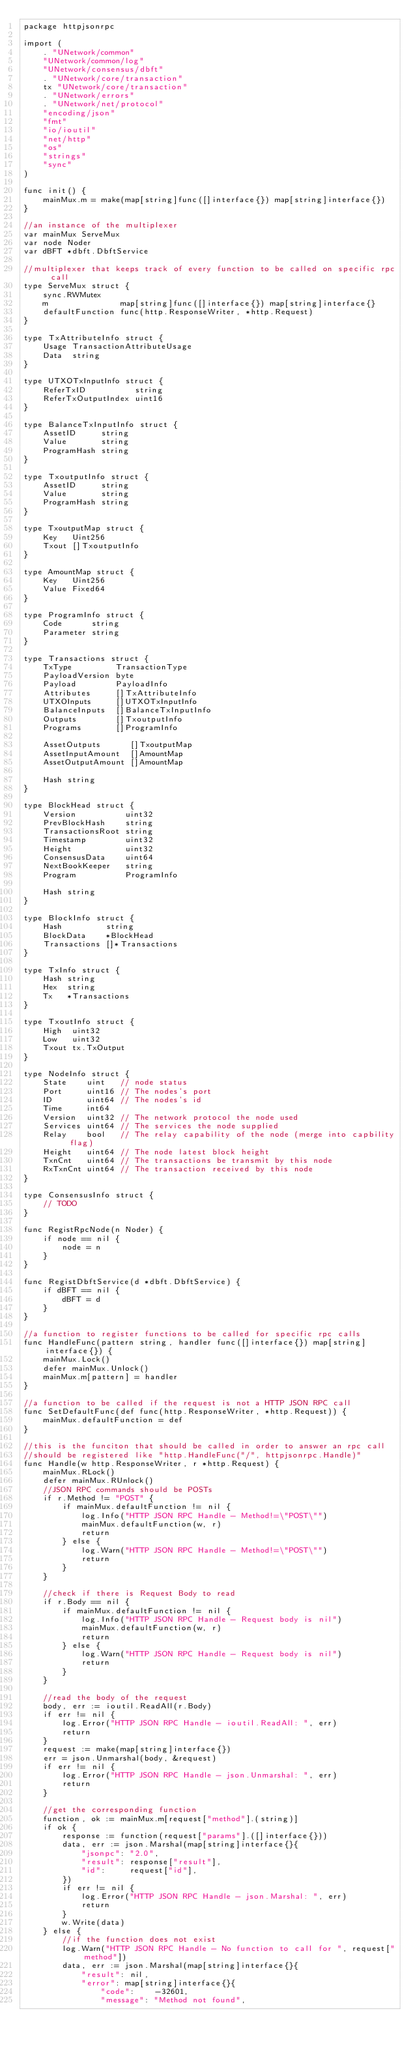<code> <loc_0><loc_0><loc_500><loc_500><_Go_>package httpjsonrpc

import (
	. "UNetwork/common"
	"UNetwork/common/log"
	"UNetwork/consensus/dbft"
	. "UNetwork/core/transaction"
	tx "UNetwork/core/transaction"
	. "UNetwork/errors"
	. "UNetwork/net/protocol"
	"encoding/json"
	"fmt"
	"io/ioutil"
	"net/http"
	"os"
	"strings"
	"sync"
)

func init() {
	mainMux.m = make(map[string]func([]interface{}) map[string]interface{})
}

//an instance of the multiplexer
var mainMux ServeMux
var node Noder
var dBFT *dbft.DbftService

//multiplexer that keeps track of every function to be called on specific rpc call
type ServeMux struct {
	sync.RWMutex
	m               map[string]func([]interface{}) map[string]interface{}
	defaultFunction func(http.ResponseWriter, *http.Request)
}

type TxAttributeInfo struct {
	Usage TransactionAttributeUsage
	Data  string
}

type UTXOTxInputInfo struct {
	ReferTxID          string
	ReferTxOutputIndex uint16
}

type BalanceTxInputInfo struct {
	AssetID     string
	Value       string
	ProgramHash string
}

type TxoutputInfo struct {
	AssetID     string
	Value       string
	ProgramHash string
}

type TxoutputMap struct {
	Key   Uint256
	Txout []TxoutputInfo
}

type AmountMap struct {
	Key   Uint256
	Value Fixed64
}

type ProgramInfo struct {
	Code      string
	Parameter string
}

type Transactions struct {
	TxType         TransactionType
	PayloadVersion byte
	Payload        PayloadInfo
	Attributes     []TxAttributeInfo
	UTXOInputs     []UTXOTxInputInfo
	BalanceInputs  []BalanceTxInputInfo
	Outputs        []TxoutputInfo
	Programs       []ProgramInfo

	AssetOutputs      []TxoutputMap
	AssetInputAmount  []AmountMap
	AssetOutputAmount []AmountMap

	Hash string
}

type BlockHead struct {
	Version          uint32
	PrevBlockHash    string
	TransactionsRoot string
	Timestamp        uint32
	Height           uint32
	ConsensusData    uint64
	NextBookKeeper   string
	Program          ProgramInfo

	Hash string
}

type BlockInfo struct {
	Hash         string
	BlockData    *BlockHead
	Transactions []*Transactions
}

type TxInfo struct {
	Hash string
	Hex  string
	Tx   *Transactions
}

type TxoutInfo struct {
	High  uint32
	Low   uint32
	Txout tx.TxOutput
}

type NodeInfo struct {
	State    uint   // node status
	Port     uint16 // The nodes's port
	ID       uint64 // The nodes's id
	Time     int64
	Version  uint32 // The network protocol the node used
	Services uint64 // The services the node supplied
	Relay    bool   // The relay capability of the node (merge into capbility flag)
	Height   uint64 // The node latest block height
	TxnCnt   uint64 // The transactions be transmit by this node
	RxTxnCnt uint64 // The transaction received by this node
}

type ConsensusInfo struct {
	// TODO
}

func RegistRpcNode(n Noder) {
	if node == nil {
		node = n
	}
}

func RegistDbftService(d *dbft.DbftService) {
	if dBFT == nil {
		dBFT = d
	}
}

//a function to register functions to be called for specific rpc calls
func HandleFunc(pattern string, handler func([]interface{}) map[string]interface{}) {
	mainMux.Lock()
	defer mainMux.Unlock()
	mainMux.m[pattern] = handler
}

//a function to be called if the request is not a HTTP JSON RPC call
func SetDefaultFunc(def func(http.ResponseWriter, *http.Request)) {
	mainMux.defaultFunction = def
}

//this is the funciton that should be called in order to answer an rpc call
//should be registered like "http.HandleFunc("/", httpjsonrpc.Handle)"
func Handle(w http.ResponseWriter, r *http.Request) {
	mainMux.RLock()
	defer mainMux.RUnlock()
	//JSON RPC commands should be POSTs
	if r.Method != "POST" {
		if mainMux.defaultFunction != nil {
			log.Info("HTTP JSON RPC Handle - Method!=\"POST\"")
			mainMux.defaultFunction(w, r)
			return
		} else {
			log.Warn("HTTP JSON RPC Handle - Method!=\"POST\"")
			return
		}
	}

	//check if there is Request Body to read
	if r.Body == nil {
		if mainMux.defaultFunction != nil {
			log.Info("HTTP JSON RPC Handle - Request body is nil")
			mainMux.defaultFunction(w, r)
			return
		} else {
			log.Warn("HTTP JSON RPC Handle - Request body is nil")
			return
		}
	}

	//read the body of the request
	body, err := ioutil.ReadAll(r.Body)
	if err != nil {
		log.Error("HTTP JSON RPC Handle - ioutil.ReadAll: ", err)
		return
	}
	request := make(map[string]interface{})
	err = json.Unmarshal(body, &request)
	if err != nil {
		log.Error("HTTP JSON RPC Handle - json.Unmarshal: ", err)
		return
	}

	//get the corresponding function
	function, ok := mainMux.m[request["method"].(string)]
	if ok {
		response := function(request["params"].([]interface{}))
		data, err := json.Marshal(map[string]interface{}{
			"jsonpc": "2.0",
			"result": response["result"],
			"id":     request["id"],
		})
		if err != nil {
			log.Error("HTTP JSON RPC Handle - json.Marshal: ", err)
			return
		}
		w.Write(data)
	} else {
		//if the function does not exist
		log.Warn("HTTP JSON RPC Handle - No function to call for ", request["method"])
		data, err := json.Marshal(map[string]interface{}{
			"result": nil,
			"error": map[string]interface{}{
				"code":    -32601,
				"message": "Method not found",</code> 